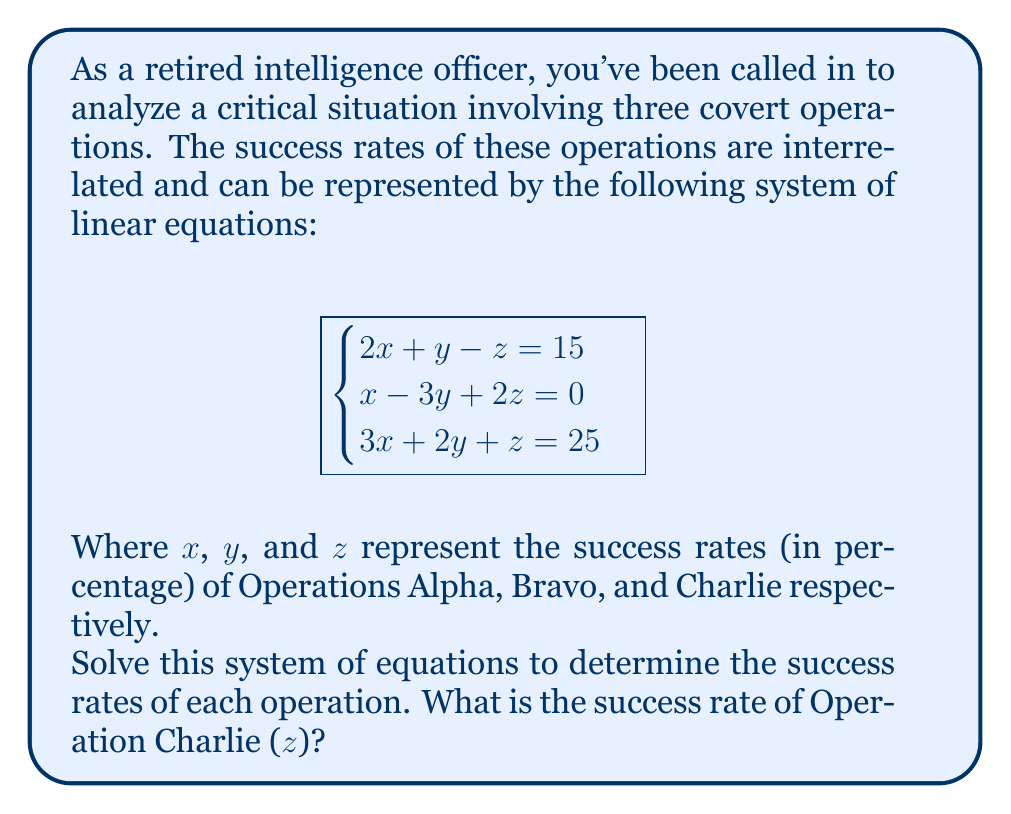Can you solve this math problem? To solve this system of linear equations, we'll use the Gaussian elimination method:

1) First, let's write the augmented matrix:

   $$\begin{bmatrix}
   2 & 1 & -1 & 15 \\
   1 & -3 & 2 & 0 \\
   3 & 2 & 1 & 25
   \end{bmatrix}$$

2) Multiply the first row by -1 and add it to the second row:

   $$\begin{bmatrix}
   2 & 1 & -1 & 15 \\
   0 & -4 & 3 & -15 \\
   3 & 2 & 1 & 25
   \end{bmatrix}$$

3) Multiply the first row by -3/2 and add it to the third row:

   $$\begin{bmatrix}
   2 & 1 & -1 & 15 \\
   0 & -4 & 3 & -15 \\
   0 & 1/2 & 5/2 & 2.5
   \end{bmatrix}$$

4) Multiply the second row by -1/8 and add it to the third row:

   $$\begin{bmatrix}
   2 & 1 & -1 & 15 \\
   0 & -4 & 3 & -15 \\
   0 & 0 & 35/8 & 4.375
   \end{bmatrix}$$

5) Now we have an upper triangular matrix. Let's solve for z:

   $\frac{35}{8}z = 4.375$
   $z = 4.375 \cdot \frac{8}{35} = 1$

6) Substitute z = 1 into the second equation:

   $-4y + 3(1) = -15$
   $-4y = -18$
   $y = 4.5$

7) Substitute y = 4.5 and z = 1 into the first equation:

   $2x + 4.5 - 1 = 15$
   $2x = 11.5$
   $x = 5.75$

Therefore, the success rates are:
x (Operation Alpha) = 5.75%
y (Operation Bravo) = 4.5%
z (Operation Charlie) = 1%
Answer: 1% 